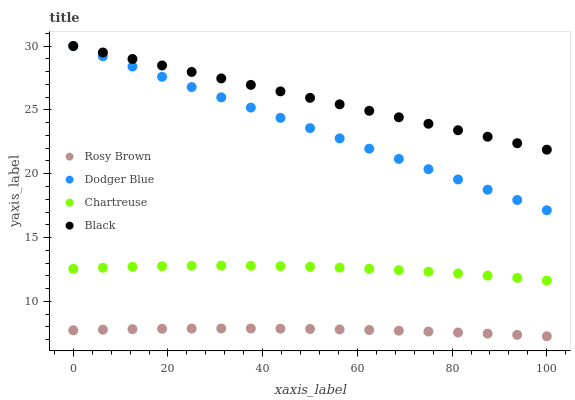Does Rosy Brown have the minimum area under the curve?
Answer yes or no. Yes. Does Black have the maximum area under the curve?
Answer yes or no. Yes. Does Chartreuse have the minimum area under the curve?
Answer yes or no. No. Does Chartreuse have the maximum area under the curve?
Answer yes or no. No. Is Black the smoothest?
Answer yes or no. Yes. Is Chartreuse the roughest?
Answer yes or no. Yes. Is Rosy Brown the smoothest?
Answer yes or no. No. Is Rosy Brown the roughest?
Answer yes or no. No. Does Rosy Brown have the lowest value?
Answer yes or no. Yes. Does Chartreuse have the lowest value?
Answer yes or no. No. Does Dodger Blue have the highest value?
Answer yes or no. Yes. Does Chartreuse have the highest value?
Answer yes or no. No. Is Rosy Brown less than Chartreuse?
Answer yes or no. Yes. Is Chartreuse greater than Rosy Brown?
Answer yes or no. Yes. Does Dodger Blue intersect Black?
Answer yes or no. Yes. Is Dodger Blue less than Black?
Answer yes or no. No. Is Dodger Blue greater than Black?
Answer yes or no. No. Does Rosy Brown intersect Chartreuse?
Answer yes or no. No. 